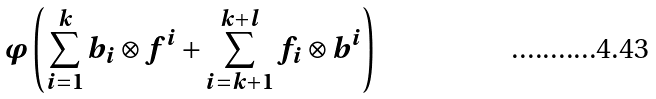<formula> <loc_0><loc_0><loc_500><loc_500>\varphi \left ( \sum _ { i = 1 } ^ { k } b _ { i } \otimes f ^ { i } + \sum _ { i = k + 1 } ^ { k + l } f _ { i } \otimes b ^ { i } \right )</formula> 